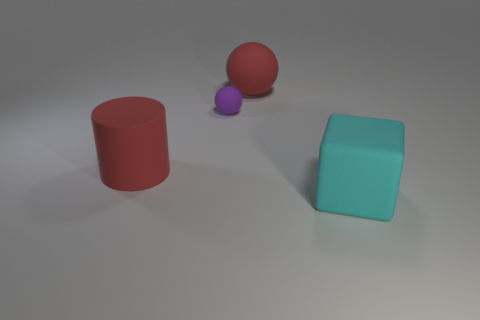How many other objects are the same material as the cyan thing?
Ensure brevity in your answer.  3. What material is the big thing that is to the right of the small purple rubber sphere and behind the cyan rubber block?
Your answer should be very brief. Rubber. Does the cyan rubber object have the same size as the red matte cylinder?
Ensure brevity in your answer.  Yes. There is a ball in front of the red matte object on the right side of the cylinder; what size is it?
Offer a terse response. Small. How many objects are on the left side of the red sphere and behind the cylinder?
Make the answer very short. 1. Is there a purple matte object left of the red matte thing that is behind the red rubber cylinder that is to the left of the red matte sphere?
Offer a very short reply. Yes. What is the shape of the cyan thing that is the same size as the red matte cylinder?
Offer a very short reply. Cube. Are there any objects of the same color as the big rubber sphere?
Your answer should be compact. Yes. Do the small purple object and the big cyan object have the same shape?
Provide a succinct answer. No. How many small things are either purple objects or cyan objects?
Your answer should be compact. 1. 